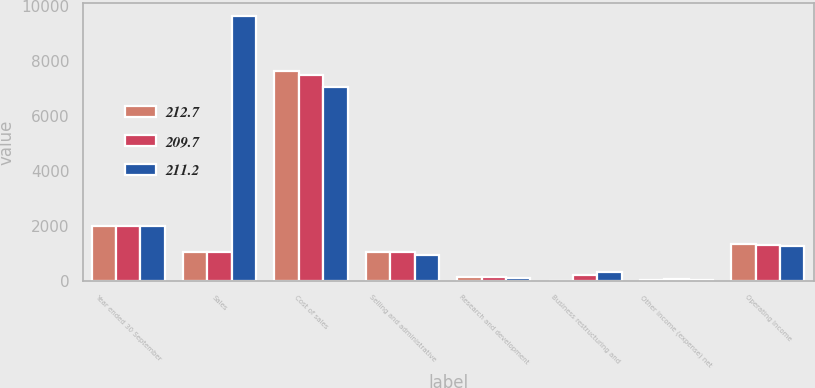<chart> <loc_0><loc_0><loc_500><loc_500><stacked_bar_chart><ecel><fcel>Year ended 30 September<fcel>Sales<fcel>Cost of sales<fcel>Selling and administrative<fcel>Research and development<fcel>Business restructuring and<fcel>Other income (expense) net<fcel>Operating Income<nl><fcel>212.7<fcel>2014<fcel>1062.8<fcel>7634.6<fcel>1059.3<fcel>141.4<fcel>12.7<fcel>52.8<fcel>1328.2<nl><fcel>209.7<fcel>2013<fcel>1062.8<fcel>7472.1<fcel>1066.3<fcel>133.7<fcel>231.6<fcel>70.2<fcel>1324.4<nl><fcel>211.2<fcel>2012<fcel>9611.7<fcel>7051.9<fcel>946.8<fcel>126.4<fcel>327.4<fcel>47.1<fcel>1282.4<nl></chart> 